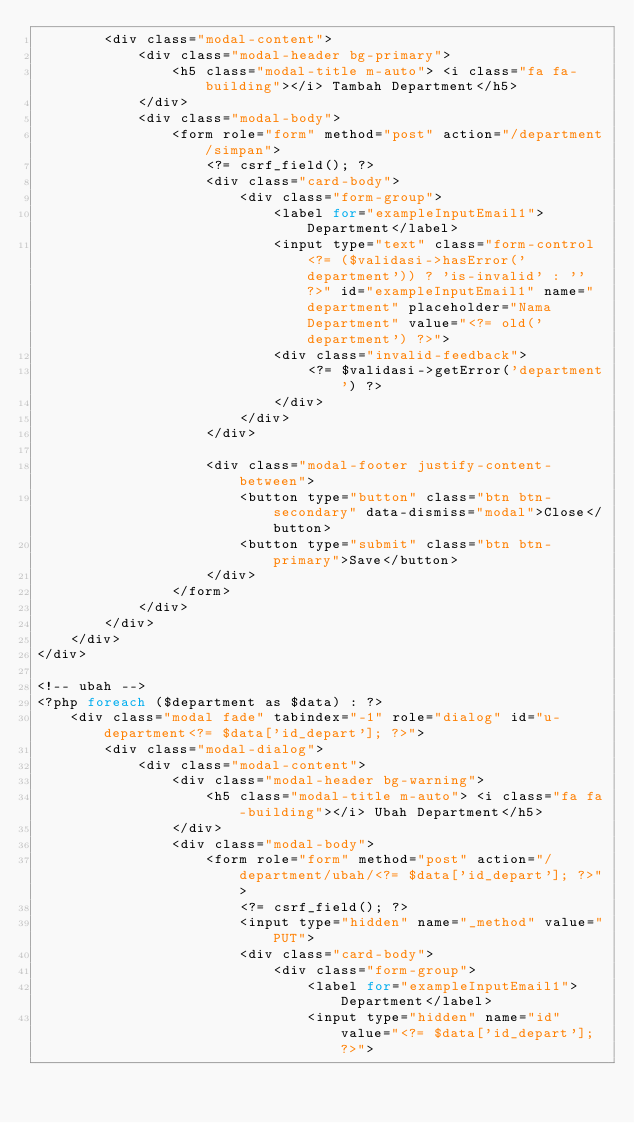Convert code to text. <code><loc_0><loc_0><loc_500><loc_500><_PHP_>        <div class="modal-content">
            <div class="modal-header bg-primary">
                <h5 class="modal-title m-auto"> <i class="fa fa-building"></i> Tambah Department</h5>
            </div>
            <div class="modal-body">
                <form role="form" method="post" action="/department/simpan">
                    <?= csrf_field(); ?>
                    <div class="card-body">
                        <div class="form-group">
                            <label for="exampleInputEmail1">Department</label>
                            <input type="text" class="form-control <?= ($validasi->hasError('department')) ? 'is-invalid' : '' ?>" id="exampleInputEmail1" name="department" placeholder="Nama Department" value="<?= old('department') ?>">
                            <div class="invalid-feedback">
                                <?= $validasi->getError('department') ?>
                            </div>
                        </div>
                    </div>

                    <div class="modal-footer justify-content-between">
                        <button type="button" class="btn btn-secondary" data-dismiss="modal">Close</button>
                        <button type="submit" class="btn btn-primary">Save</button>
                    </div>
                </form>
            </div>
        </div>
    </div>
</div>

<!-- ubah -->
<?php foreach ($department as $data) : ?>
    <div class="modal fade" tabindex="-1" role="dialog" id="u-department<?= $data['id_depart']; ?>">
        <div class="modal-dialog">
            <div class="modal-content">
                <div class="modal-header bg-warning">
                    <h5 class="modal-title m-auto"> <i class="fa fa-building"></i> Ubah Department</h5>
                </div>
                <div class="modal-body">
                    <form role="form" method="post" action="/department/ubah/<?= $data['id_depart']; ?>">
                        <?= csrf_field(); ?>
                        <input type="hidden" name="_method" value="PUT">
                        <div class="card-body">
                            <div class="form-group">
                                <label for="exampleInputEmail1">Department</label>
                                <input type="hidden" name="id" value="<?= $data['id_depart']; ?>"></code> 